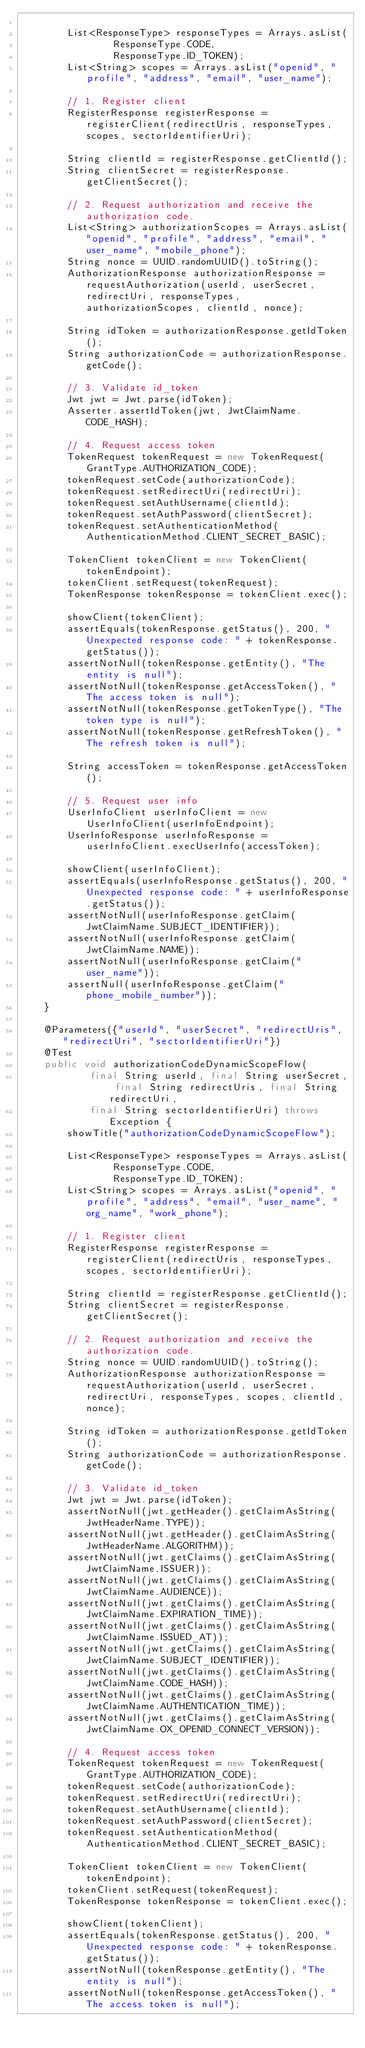Convert code to text. <code><loc_0><loc_0><loc_500><loc_500><_Java_>
        List<ResponseType> responseTypes = Arrays.asList(
                ResponseType.CODE,
                ResponseType.ID_TOKEN);
        List<String> scopes = Arrays.asList("openid", "profile", "address", "email", "user_name");

        // 1. Register client
        RegisterResponse registerResponse = registerClient(redirectUris, responseTypes, scopes, sectorIdentifierUri);

        String clientId = registerResponse.getClientId();
        String clientSecret = registerResponse.getClientSecret();

        // 2. Request authorization and receive the authorization code.
        List<String> authorizationScopes = Arrays.asList("openid", "profile", "address", "email", "user_name", "mobile_phone");
        String nonce = UUID.randomUUID().toString();
        AuthorizationResponse authorizationResponse = requestAuthorization(userId, userSecret, redirectUri, responseTypes, authorizationScopes, clientId, nonce);

        String idToken = authorizationResponse.getIdToken();
        String authorizationCode = authorizationResponse.getCode();

        // 3. Validate id_token
        Jwt jwt = Jwt.parse(idToken);
        Asserter.assertIdToken(jwt, JwtClaimName.CODE_HASH);

        // 4. Request access token
        TokenRequest tokenRequest = new TokenRequest(GrantType.AUTHORIZATION_CODE);
        tokenRequest.setCode(authorizationCode);
        tokenRequest.setRedirectUri(redirectUri);
        tokenRequest.setAuthUsername(clientId);
        tokenRequest.setAuthPassword(clientSecret);
        tokenRequest.setAuthenticationMethod(AuthenticationMethod.CLIENT_SECRET_BASIC);

        TokenClient tokenClient = new TokenClient(tokenEndpoint);
        tokenClient.setRequest(tokenRequest);
        TokenResponse tokenResponse = tokenClient.exec();

        showClient(tokenClient);
        assertEquals(tokenResponse.getStatus(), 200, "Unexpected response code: " + tokenResponse.getStatus());
        assertNotNull(tokenResponse.getEntity(), "The entity is null");
        assertNotNull(tokenResponse.getAccessToken(), "The access token is null");
        assertNotNull(tokenResponse.getTokenType(), "The token type is null");
        assertNotNull(tokenResponse.getRefreshToken(), "The refresh token is null");

        String accessToken = tokenResponse.getAccessToken();

        // 5. Request user info
        UserInfoClient userInfoClient = new UserInfoClient(userInfoEndpoint);
        UserInfoResponse userInfoResponse = userInfoClient.execUserInfo(accessToken);

        showClient(userInfoClient);
        assertEquals(userInfoResponse.getStatus(), 200, "Unexpected response code: " + userInfoResponse.getStatus());
        assertNotNull(userInfoResponse.getClaim(JwtClaimName.SUBJECT_IDENTIFIER));
        assertNotNull(userInfoResponse.getClaim(JwtClaimName.NAME));
        assertNotNull(userInfoResponse.getClaim("user_name"));
        assertNull(userInfoResponse.getClaim("phone_mobile_number"));
    }

    @Parameters({"userId", "userSecret", "redirectUris", "redirectUri", "sectorIdentifierUri"})
    @Test
    public void authorizationCodeDynamicScopeFlow(
            final String userId, final String userSecret, final String redirectUris, final String redirectUri,
            final String sectorIdentifierUri) throws Exception {
        showTitle("authorizationCodeDynamicScopeFlow");

        List<ResponseType> responseTypes = Arrays.asList(
                ResponseType.CODE,
                ResponseType.ID_TOKEN);
        List<String> scopes = Arrays.asList("openid", "profile", "address", "email", "user_name", "org_name", "work_phone");

        // 1. Register client
        RegisterResponse registerResponse = registerClient(redirectUris, responseTypes, scopes, sectorIdentifierUri);

        String clientId = registerResponse.getClientId();
        String clientSecret = registerResponse.getClientSecret();

        // 2. Request authorization and receive the authorization code.
        String nonce = UUID.randomUUID().toString();
        AuthorizationResponse authorizationResponse = requestAuthorization(userId, userSecret, redirectUri, responseTypes, scopes, clientId, nonce);

        String idToken = authorizationResponse.getIdToken();
        String authorizationCode = authorizationResponse.getCode();

        // 3. Validate id_token
        Jwt jwt = Jwt.parse(idToken);
        assertNotNull(jwt.getHeader().getClaimAsString(JwtHeaderName.TYPE));
        assertNotNull(jwt.getHeader().getClaimAsString(JwtHeaderName.ALGORITHM));
        assertNotNull(jwt.getClaims().getClaimAsString(JwtClaimName.ISSUER));
        assertNotNull(jwt.getClaims().getClaimAsString(JwtClaimName.AUDIENCE));
        assertNotNull(jwt.getClaims().getClaimAsString(JwtClaimName.EXPIRATION_TIME));
        assertNotNull(jwt.getClaims().getClaimAsString(JwtClaimName.ISSUED_AT));
        assertNotNull(jwt.getClaims().getClaimAsString(JwtClaimName.SUBJECT_IDENTIFIER));
        assertNotNull(jwt.getClaims().getClaimAsString(JwtClaimName.CODE_HASH));
        assertNotNull(jwt.getClaims().getClaimAsString(JwtClaimName.AUTHENTICATION_TIME));
        assertNotNull(jwt.getClaims().getClaimAsString(JwtClaimName.OX_OPENID_CONNECT_VERSION));

        // 4. Request access token
        TokenRequest tokenRequest = new TokenRequest(GrantType.AUTHORIZATION_CODE);
        tokenRequest.setCode(authorizationCode);
        tokenRequest.setRedirectUri(redirectUri);
        tokenRequest.setAuthUsername(clientId);
        tokenRequest.setAuthPassword(clientSecret);
        tokenRequest.setAuthenticationMethod(AuthenticationMethod.CLIENT_SECRET_BASIC);

        TokenClient tokenClient = new TokenClient(tokenEndpoint);
        tokenClient.setRequest(tokenRequest);
        TokenResponse tokenResponse = tokenClient.exec();

        showClient(tokenClient);
        assertEquals(tokenResponse.getStatus(), 200, "Unexpected response code: " + tokenResponse.getStatus());
        assertNotNull(tokenResponse.getEntity(), "The entity is null");
        assertNotNull(tokenResponse.getAccessToken(), "The access token is null");</code> 